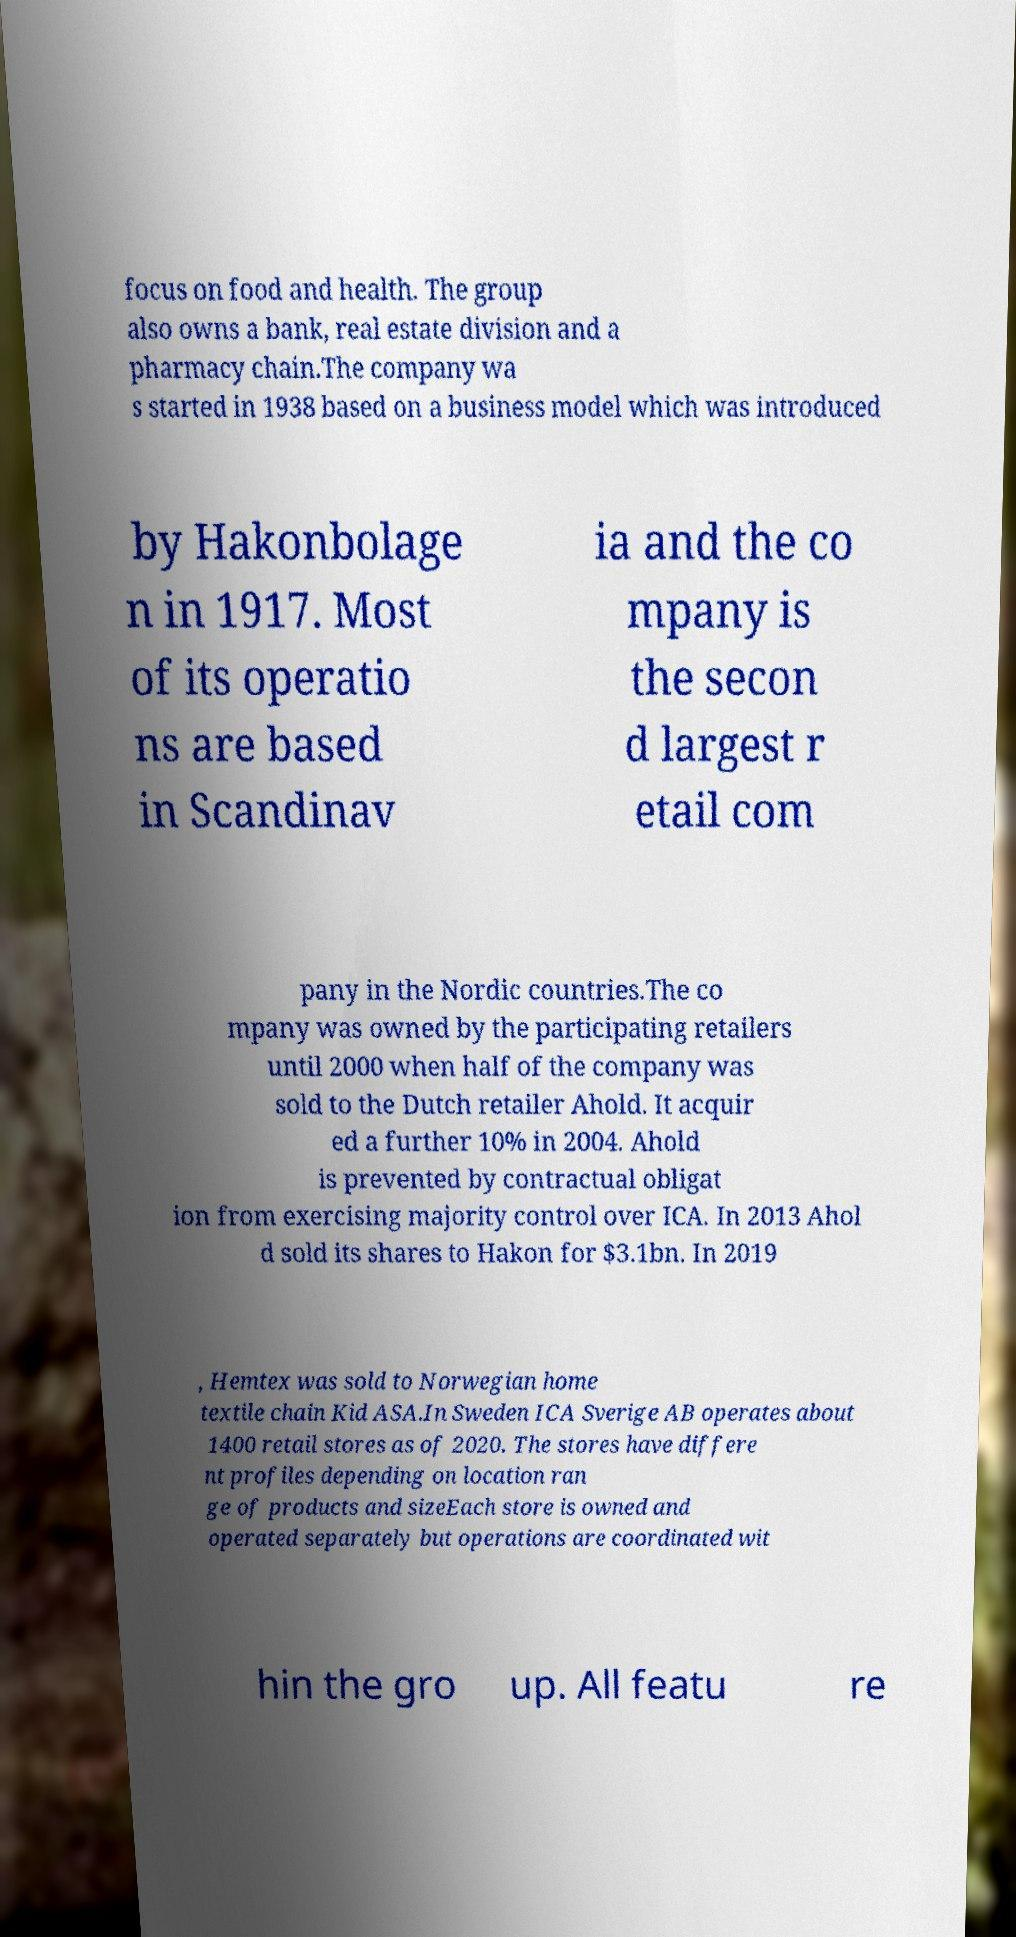Can you read and provide the text displayed in the image?This photo seems to have some interesting text. Can you extract and type it out for me? focus on food and health. The group also owns a bank, real estate division and a pharmacy chain.The company wa s started in 1938 based on a business model which was introduced by Hakonbolage n in 1917. Most of its operatio ns are based in Scandinav ia and the co mpany is the secon d largest r etail com pany in the Nordic countries.The co mpany was owned by the participating retailers until 2000 when half of the company was sold to the Dutch retailer Ahold. It acquir ed a further 10% in 2004. Ahold is prevented by contractual obligat ion from exercising majority control over ICA. In 2013 Ahol d sold its shares to Hakon for $3.1bn. In 2019 , Hemtex was sold to Norwegian home textile chain Kid ASA.In Sweden ICA Sverige AB operates about 1400 retail stores as of 2020. The stores have differe nt profiles depending on location ran ge of products and sizeEach store is owned and operated separately but operations are coordinated wit hin the gro up. All featu re 